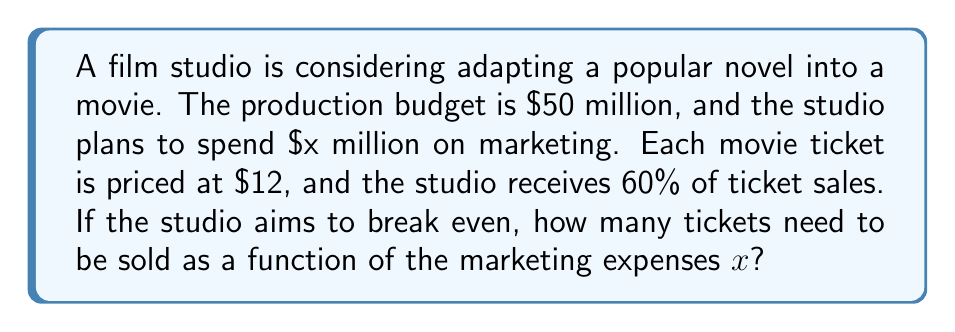Give your solution to this math problem. Let's approach this step-by-step:

1) First, let's define our variables:
   $x$ = marketing expenses in millions
   $y$ = number of tickets sold in millions

2) The total cost for the studio is the sum of production budget and marketing expenses:
   Total Cost = $50 + x$ million

3) The revenue per ticket for the studio is 60% of the ticket price:
   Revenue per ticket = $0.60 * $12 = $7.20

4) The total revenue is the number of tickets sold multiplied by the revenue per ticket:
   Total Revenue = $7.20y$ million

5) At the break-even point, Total Cost equals Total Revenue:
   $50 + x = 7.20y$

6) Solving for $y$:
   $y = \frac{50 + x}{7.20}$

7) To express $y$ in terms of actual tickets (not millions), we multiply by 1,000,000:
   $y = \frac{50,000,000 + 1,000,000x}{7.20}$

8) Simplifying:
   $y = \frac{50,000,000 + 1,000,000x}{7.20} = 6,944,444.44 + 138,888.89x$

Therefore, the number of tickets needed to break even is $6,944,444 + 138,889x$, where $x$ is the marketing expense in millions.
Answer: $6,944,444 + 138,889x$ tickets 